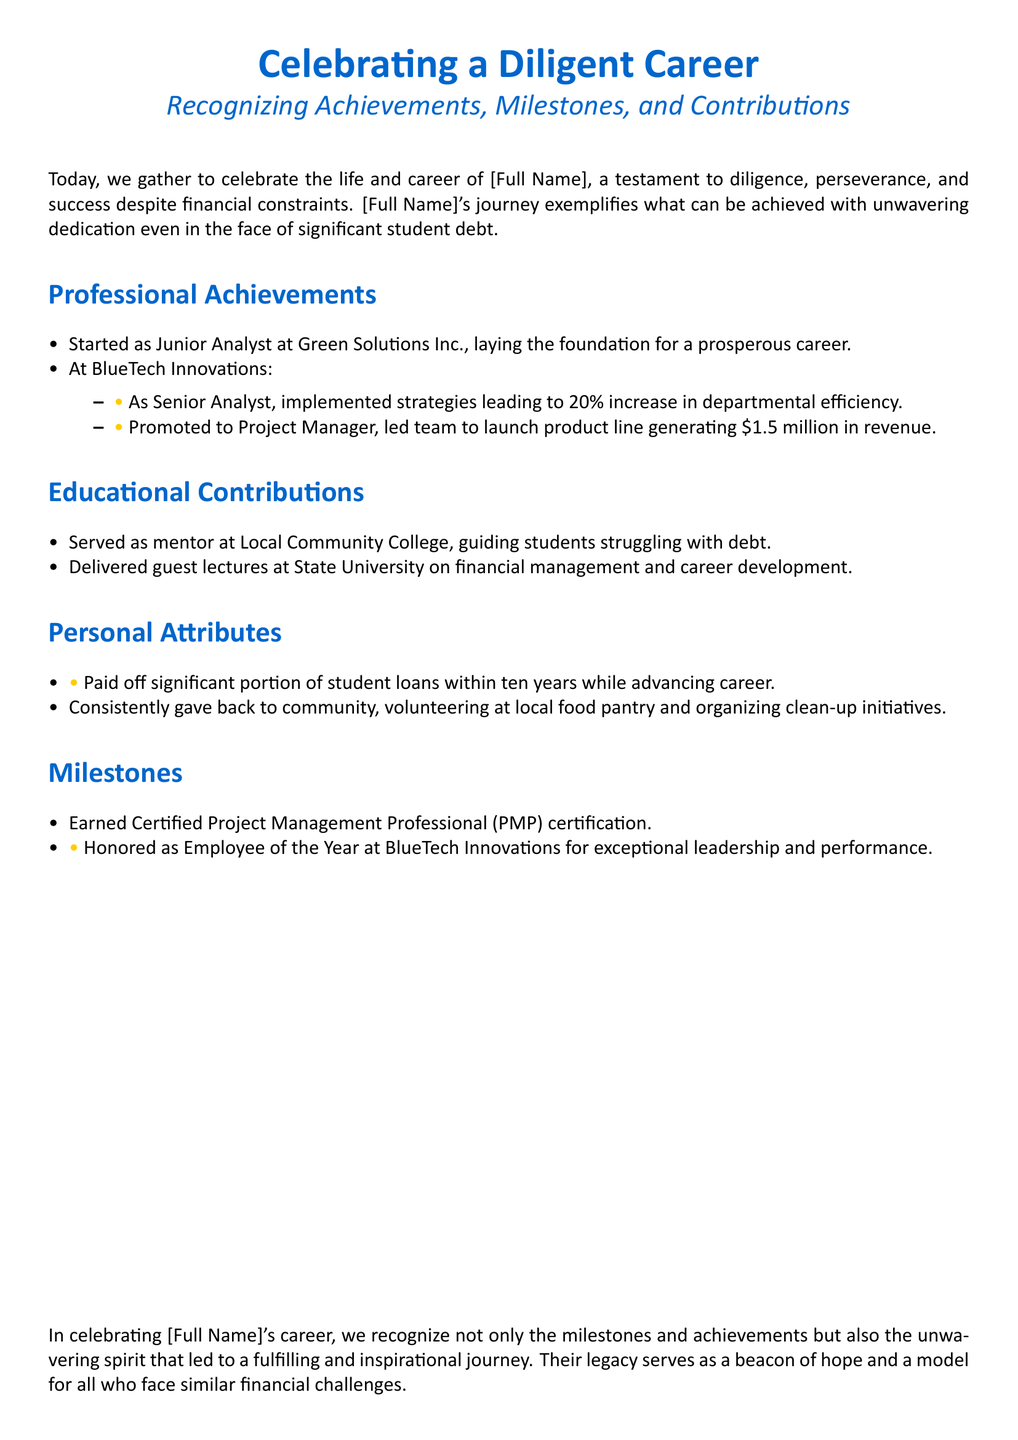what position did [Full Name] start at Green Solutions Inc.? The document states that [Full Name] started as a Junior Analyst at Green Solutions Inc.
Answer: Junior Analyst what percentage increase in efficiency was achieved at BlueTech Innovations? The document mentions a 20% increase in departmental efficiency from strategies implemented as Senior Analyst.
Answer: 20% how much revenue did the product line generate under [Full Name]'s leadership? It is stated that the product line launched under [Full Name]'s management generated $1.5 million in revenue.
Answer: $1.5 million what certification did [Full Name] earn? The document indicates that [Full Name] earned the Certified Project Management Professional (PMP) certification.
Answer: Certified Project Management Professional (PMP) how long did it take [Full Name] to pay off a significant portion of student loans? The document notes that [Full Name] paid off a significant portion of student loans within ten years.
Answer: ten years what was [Full Name] honored as at BlueTech Innovations? According to the document, [Full Name] was honored as Employee of the Year for exceptional leadership and performance at BlueTech Innovations.
Answer: Employee of the Year what community role did [Full Name] serve in at Local Community College? The document states that [Full Name] served as a mentor at Local Community College, guiding students struggling with debt.
Answer: mentor what is the overarching theme of the document? The document celebrates the achievements and contributions of [Full Name] in light of their diligent career despite financial constraints.
Answer: Celebrating achievements 